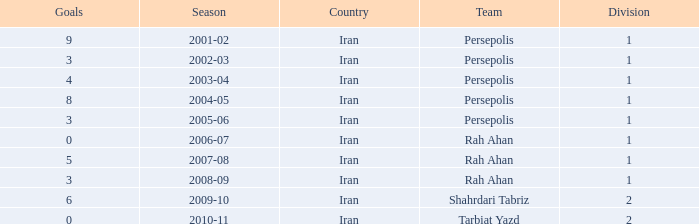What is the average Goals, when Team is "Rah Ahan", and when Division is less than 1? None. 